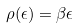<formula> <loc_0><loc_0><loc_500><loc_500>\rho ( \epsilon ) = \beta \epsilon</formula> 